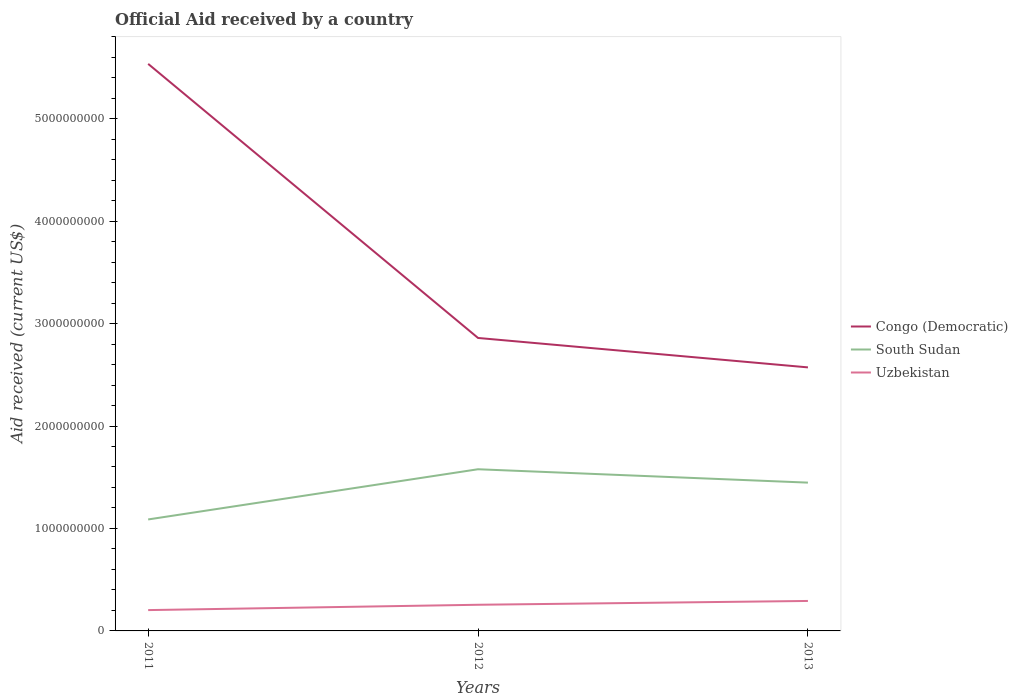How many different coloured lines are there?
Offer a terse response. 3. Is the number of lines equal to the number of legend labels?
Offer a very short reply. Yes. Across all years, what is the maximum net official aid received in South Sudan?
Your answer should be very brief. 1.09e+09. In which year was the net official aid received in Uzbekistan maximum?
Offer a terse response. 2011. What is the total net official aid received in Uzbekistan in the graph?
Provide a succinct answer. -3.73e+07. What is the difference between the highest and the second highest net official aid received in Congo (Democratic)?
Provide a short and direct response. 2.96e+09. How many lines are there?
Ensure brevity in your answer.  3. Does the graph contain any zero values?
Your response must be concise. No. Does the graph contain grids?
Offer a very short reply. No. How many legend labels are there?
Your answer should be very brief. 3. What is the title of the graph?
Keep it short and to the point. Official Aid received by a country. What is the label or title of the Y-axis?
Provide a short and direct response. Aid received (current US$). What is the Aid received (current US$) in Congo (Democratic) in 2011?
Offer a terse response. 5.53e+09. What is the Aid received (current US$) of South Sudan in 2011?
Your answer should be compact. 1.09e+09. What is the Aid received (current US$) in Uzbekistan in 2011?
Provide a short and direct response. 2.03e+08. What is the Aid received (current US$) in Congo (Democratic) in 2012?
Your answer should be compact. 2.86e+09. What is the Aid received (current US$) in South Sudan in 2012?
Provide a succinct answer. 1.58e+09. What is the Aid received (current US$) in Uzbekistan in 2012?
Give a very brief answer. 2.55e+08. What is the Aid received (current US$) of Congo (Democratic) in 2013?
Provide a short and direct response. 2.57e+09. What is the Aid received (current US$) of South Sudan in 2013?
Provide a short and direct response. 1.45e+09. What is the Aid received (current US$) of Uzbekistan in 2013?
Offer a very short reply. 2.93e+08. Across all years, what is the maximum Aid received (current US$) in Congo (Democratic)?
Your answer should be very brief. 5.53e+09. Across all years, what is the maximum Aid received (current US$) of South Sudan?
Offer a terse response. 1.58e+09. Across all years, what is the maximum Aid received (current US$) in Uzbekistan?
Make the answer very short. 2.93e+08. Across all years, what is the minimum Aid received (current US$) in Congo (Democratic)?
Your answer should be compact. 2.57e+09. Across all years, what is the minimum Aid received (current US$) of South Sudan?
Make the answer very short. 1.09e+09. Across all years, what is the minimum Aid received (current US$) in Uzbekistan?
Make the answer very short. 2.03e+08. What is the total Aid received (current US$) of Congo (Democratic) in the graph?
Keep it short and to the point. 1.10e+1. What is the total Aid received (current US$) of South Sudan in the graph?
Your answer should be compact. 4.11e+09. What is the total Aid received (current US$) in Uzbekistan in the graph?
Keep it short and to the point. 7.51e+08. What is the difference between the Aid received (current US$) in Congo (Democratic) in 2011 and that in 2012?
Your response must be concise. 2.68e+09. What is the difference between the Aid received (current US$) in South Sudan in 2011 and that in 2012?
Your answer should be very brief. -4.90e+08. What is the difference between the Aid received (current US$) in Uzbekistan in 2011 and that in 2012?
Provide a succinct answer. -5.20e+07. What is the difference between the Aid received (current US$) of Congo (Democratic) in 2011 and that in 2013?
Keep it short and to the point. 2.96e+09. What is the difference between the Aid received (current US$) in South Sudan in 2011 and that in 2013?
Provide a short and direct response. -3.59e+08. What is the difference between the Aid received (current US$) in Uzbekistan in 2011 and that in 2013?
Provide a succinct answer. -8.93e+07. What is the difference between the Aid received (current US$) of Congo (Democratic) in 2012 and that in 2013?
Ensure brevity in your answer.  2.87e+08. What is the difference between the Aid received (current US$) in South Sudan in 2012 and that in 2013?
Make the answer very short. 1.31e+08. What is the difference between the Aid received (current US$) in Uzbekistan in 2012 and that in 2013?
Provide a short and direct response. -3.73e+07. What is the difference between the Aid received (current US$) of Congo (Democratic) in 2011 and the Aid received (current US$) of South Sudan in 2012?
Give a very brief answer. 3.96e+09. What is the difference between the Aid received (current US$) of Congo (Democratic) in 2011 and the Aid received (current US$) of Uzbekistan in 2012?
Give a very brief answer. 5.28e+09. What is the difference between the Aid received (current US$) in South Sudan in 2011 and the Aid received (current US$) in Uzbekistan in 2012?
Provide a succinct answer. 8.33e+08. What is the difference between the Aid received (current US$) in Congo (Democratic) in 2011 and the Aid received (current US$) in South Sudan in 2013?
Your answer should be very brief. 4.09e+09. What is the difference between the Aid received (current US$) of Congo (Democratic) in 2011 and the Aid received (current US$) of Uzbekistan in 2013?
Ensure brevity in your answer.  5.24e+09. What is the difference between the Aid received (current US$) in South Sudan in 2011 and the Aid received (current US$) in Uzbekistan in 2013?
Ensure brevity in your answer.  7.95e+08. What is the difference between the Aid received (current US$) of Congo (Democratic) in 2012 and the Aid received (current US$) of South Sudan in 2013?
Ensure brevity in your answer.  1.41e+09. What is the difference between the Aid received (current US$) in Congo (Democratic) in 2012 and the Aid received (current US$) in Uzbekistan in 2013?
Provide a succinct answer. 2.57e+09. What is the difference between the Aid received (current US$) in South Sudan in 2012 and the Aid received (current US$) in Uzbekistan in 2013?
Make the answer very short. 1.29e+09. What is the average Aid received (current US$) of Congo (Democratic) per year?
Your answer should be compact. 3.66e+09. What is the average Aid received (current US$) in South Sudan per year?
Ensure brevity in your answer.  1.37e+09. What is the average Aid received (current US$) in Uzbekistan per year?
Ensure brevity in your answer.  2.50e+08. In the year 2011, what is the difference between the Aid received (current US$) in Congo (Democratic) and Aid received (current US$) in South Sudan?
Ensure brevity in your answer.  4.45e+09. In the year 2011, what is the difference between the Aid received (current US$) of Congo (Democratic) and Aid received (current US$) of Uzbekistan?
Provide a succinct answer. 5.33e+09. In the year 2011, what is the difference between the Aid received (current US$) in South Sudan and Aid received (current US$) in Uzbekistan?
Give a very brief answer. 8.85e+08. In the year 2012, what is the difference between the Aid received (current US$) in Congo (Democratic) and Aid received (current US$) in South Sudan?
Offer a very short reply. 1.28e+09. In the year 2012, what is the difference between the Aid received (current US$) of Congo (Democratic) and Aid received (current US$) of Uzbekistan?
Your answer should be very brief. 2.60e+09. In the year 2012, what is the difference between the Aid received (current US$) of South Sudan and Aid received (current US$) of Uzbekistan?
Your answer should be compact. 1.32e+09. In the year 2013, what is the difference between the Aid received (current US$) of Congo (Democratic) and Aid received (current US$) of South Sudan?
Give a very brief answer. 1.12e+09. In the year 2013, what is the difference between the Aid received (current US$) of Congo (Democratic) and Aid received (current US$) of Uzbekistan?
Make the answer very short. 2.28e+09. In the year 2013, what is the difference between the Aid received (current US$) in South Sudan and Aid received (current US$) in Uzbekistan?
Offer a terse response. 1.15e+09. What is the ratio of the Aid received (current US$) in Congo (Democratic) in 2011 to that in 2012?
Offer a very short reply. 1.94. What is the ratio of the Aid received (current US$) in South Sudan in 2011 to that in 2012?
Offer a very short reply. 0.69. What is the ratio of the Aid received (current US$) of Uzbekistan in 2011 to that in 2012?
Your answer should be very brief. 0.8. What is the ratio of the Aid received (current US$) of Congo (Democratic) in 2011 to that in 2013?
Your response must be concise. 2.15. What is the ratio of the Aid received (current US$) of South Sudan in 2011 to that in 2013?
Make the answer very short. 0.75. What is the ratio of the Aid received (current US$) of Uzbekistan in 2011 to that in 2013?
Offer a very short reply. 0.69. What is the ratio of the Aid received (current US$) of Congo (Democratic) in 2012 to that in 2013?
Your answer should be very brief. 1.11. What is the ratio of the Aid received (current US$) in South Sudan in 2012 to that in 2013?
Make the answer very short. 1.09. What is the ratio of the Aid received (current US$) in Uzbekistan in 2012 to that in 2013?
Offer a very short reply. 0.87. What is the difference between the highest and the second highest Aid received (current US$) in Congo (Democratic)?
Give a very brief answer. 2.68e+09. What is the difference between the highest and the second highest Aid received (current US$) in South Sudan?
Make the answer very short. 1.31e+08. What is the difference between the highest and the second highest Aid received (current US$) in Uzbekistan?
Provide a succinct answer. 3.73e+07. What is the difference between the highest and the lowest Aid received (current US$) in Congo (Democratic)?
Keep it short and to the point. 2.96e+09. What is the difference between the highest and the lowest Aid received (current US$) of South Sudan?
Your response must be concise. 4.90e+08. What is the difference between the highest and the lowest Aid received (current US$) of Uzbekistan?
Your answer should be compact. 8.93e+07. 